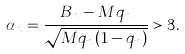<formula> <loc_0><loc_0><loc_500><loc_500>\alpha _ { n } = \frac { B _ { n } - M q _ { n } } { \sqrt { M q _ { n } ( 1 - q _ { n } ) } } > 3 .</formula> 